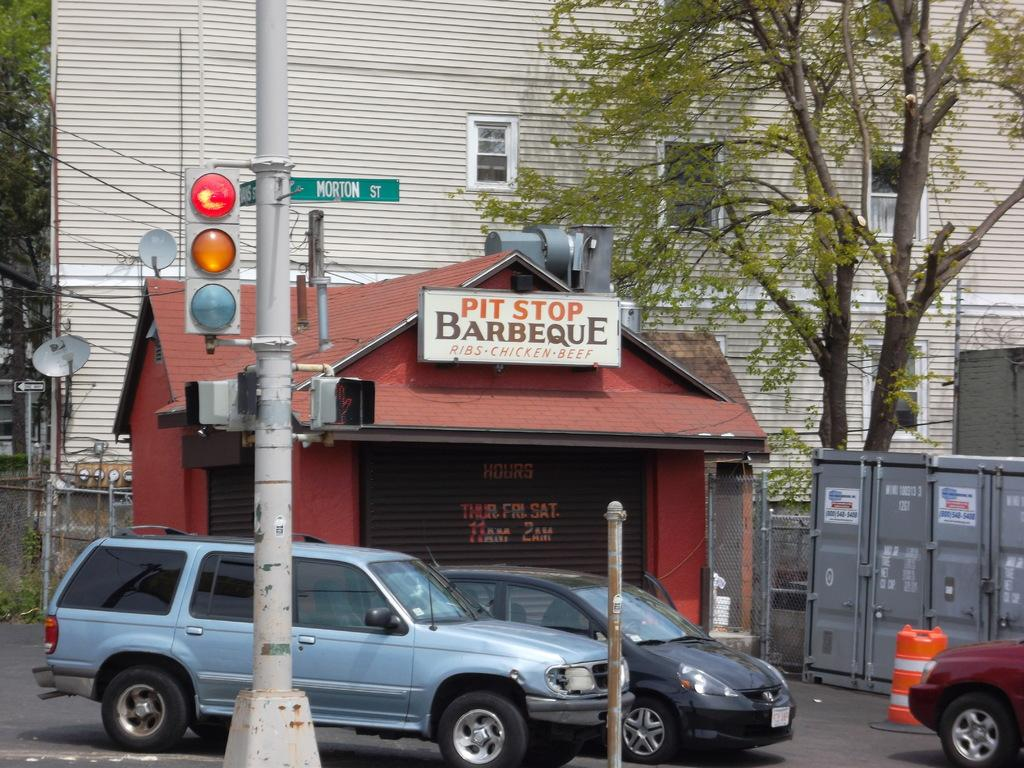What is the main object in the image? There is a pole in the image. What else can be seen in the image besides the pole? There are cars on a road in the image. What is visible in the background of the image? There is a shop, a building, and trees in the background of the image. What type of bread can be seen hanging from the pole in the image? There is no bread present in the image, and the pole is not holding any bread. 